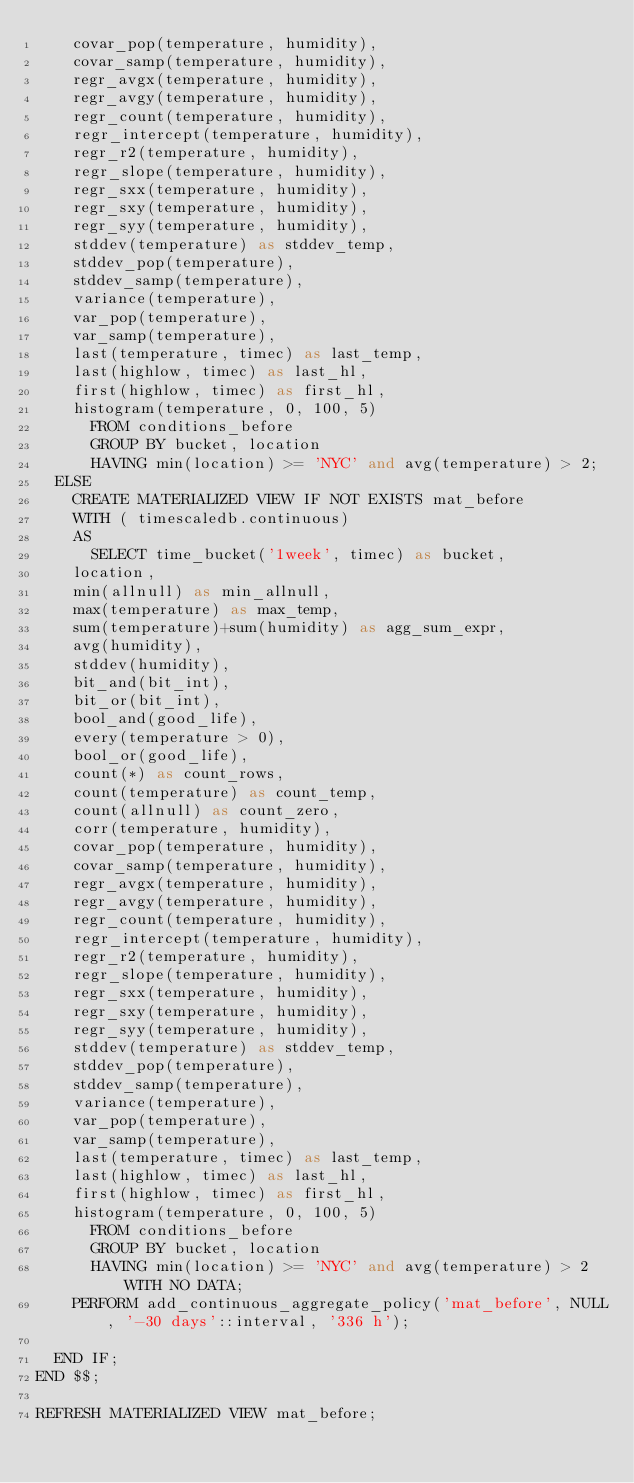<code> <loc_0><loc_0><loc_500><loc_500><_SQL_>	covar_pop(temperature, humidity),
	covar_samp(temperature, humidity),
	regr_avgx(temperature, humidity),
	regr_avgy(temperature, humidity),
	regr_count(temperature, humidity),
	regr_intercept(temperature, humidity),
	regr_r2(temperature, humidity),
	regr_slope(temperature, humidity),
	regr_sxx(temperature, humidity),
	regr_sxy(temperature, humidity),
	regr_syy(temperature, humidity),
	stddev(temperature) as stddev_temp,
	stddev_pop(temperature),
	stddev_samp(temperature),
	variance(temperature),
	var_pop(temperature),
	var_samp(temperature),
	last(temperature, timec) as last_temp,
	last(highlow, timec) as last_hl,
	first(highlow, timec) as first_hl,
	histogram(temperature, 0, 100, 5)
      FROM conditions_before
      GROUP BY bucket, location
      HAVING min(location) >= 'NYC' and avg(temperature) > 2;
  ELSE
    CREATE MATERIALIZED VIEW IF NOT EXISTS mat_before
    WITH ( timescaledb.continuous)
    AS
      SELECT time_bucket('1week', timec) as bucket,
	location,
	min(allnull) as min_allnull,
	max(temperature) as max_temp,
	sum(temperature)+sum(humidity) as agg_sum_expr,
	avg(humidity),
	stddev(humidity),
	bit_and(bit_int),
	bit_or(bit_int),
	bool_and(good_life),
	every(temperature > 0),
	bool_or(good_life),
	count(*) as count_rows,
	count(temperature) as count_temp,
	count(allnull) as count_zero,
	corr(temperature, humidity),
	covar_pop(temperature, humidity),
	covar_samp(temperature, humidity),
	regr_avgx(temperature, humidity),
	regr_avgy(temperature, humidity),
	regr_count(temperature, humidity),
	regr_intercept(temperature, humidity),
	regr_r2(temperature, humidity),
	regr_slope(temperature, humidity),
	regr_sxx(temperature, humidity),
	regr_sxy(temperature, humidity),
	regr_syy(temperature, humidity),
	stddev(temperature) as stddev_temp,
	stddev_pop(temperature),
	stddev_samp(temperature),
	variance(temperature),
	var_pop(temperature),
	var_samp(temperature),
	last(temperature, timec) as last_temp,
	last(highlow, timec) as last_hl,
	first(highlow, timec) as first_hl,
	histogram(temperature, 0, 100, 5)
      FROM conditions_before
      GROUP BY bucket, location
      HAVING min(location) >= 'NYC' and avg(temperature) > 2 WITH NO DATA;
    PERFORM add_continuous_aggregate_policy('mat_before', NULL, '-30 days'::interval, '336 h');

  END IF;
END $$;

REFRESH MATERIALIZED VIEW mat_before;
</code> 